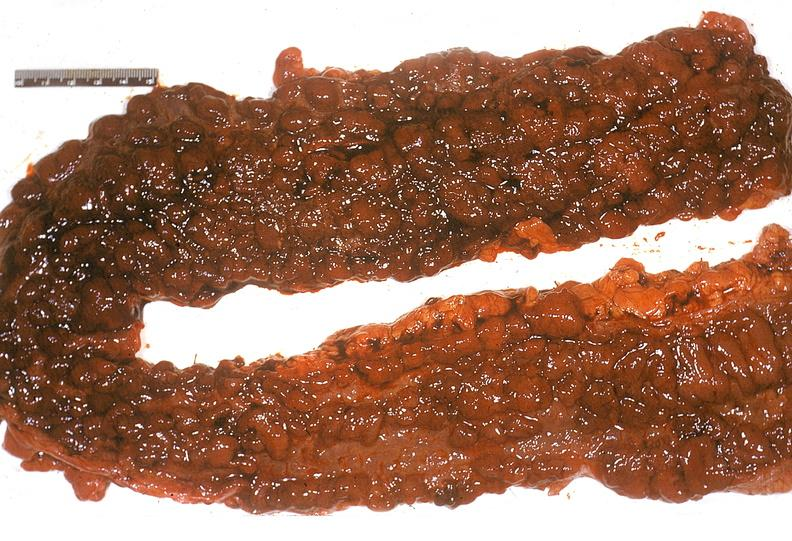does this image show colon, ulcerative colitis?
Answer the question using a single word or phrase. Yes 